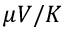Convert formula to latex. <formula><loc_0><loc_0><loc_500><loc_500>\mu V / K</formula> 